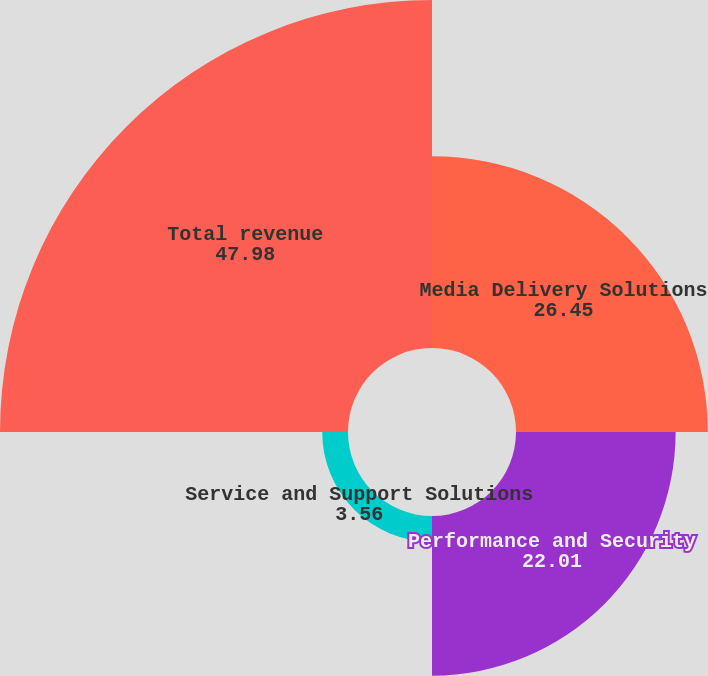<chart> <loc_0><loc_0><loc_500><loc_500><pie_chart><fcel>Media Delivery Solutions<fcel>Performance and Security<fcel>Service and Support Solutions<fcel>Total revenue<nl><fcel>26.45%<fcel>22.01%<fcel>3.56%<fcel>47.98%<nl></chart> 